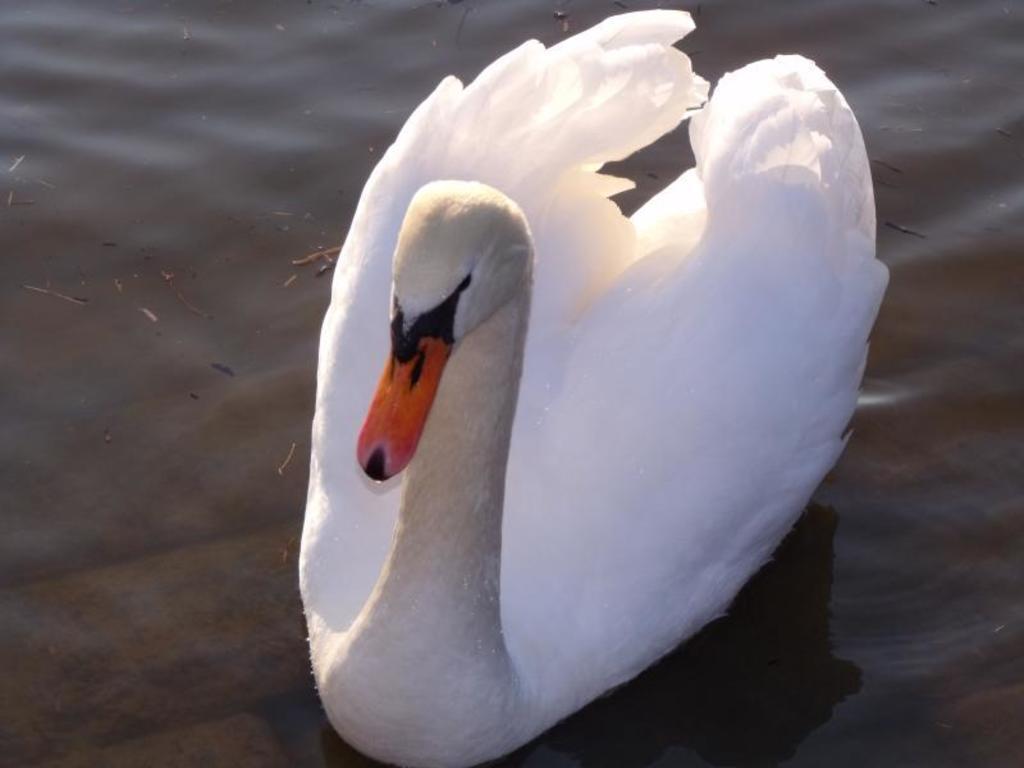Describe this image in one or two sentences. The picture consists of a swan in the water. 